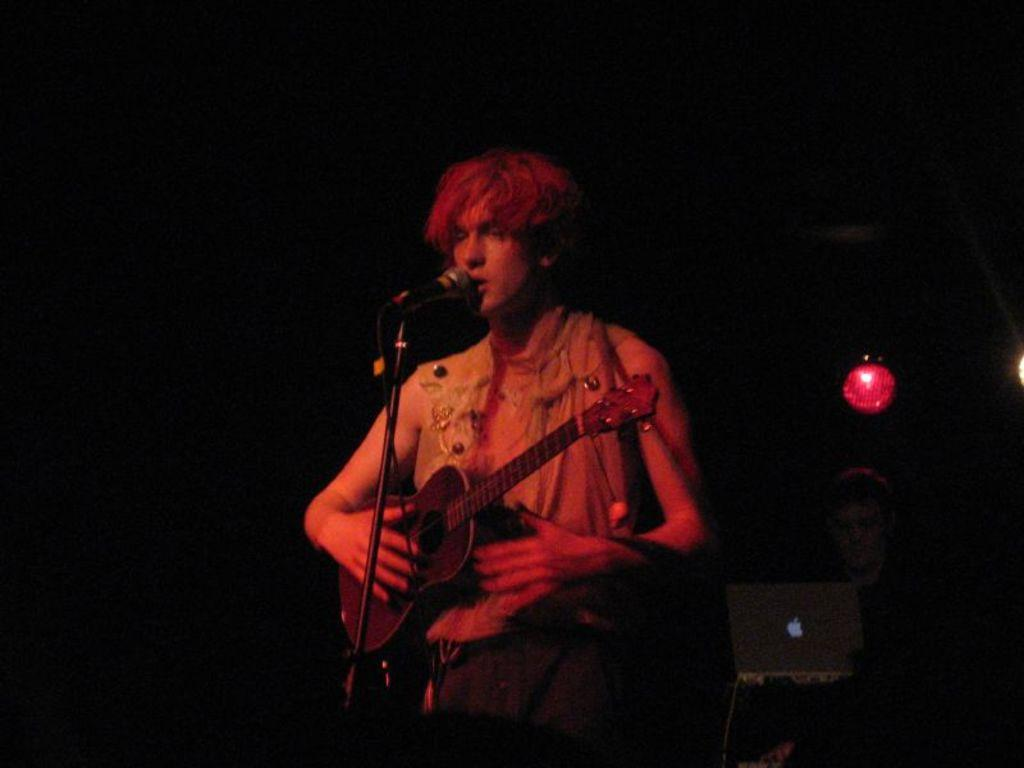What is the man in the image doing? The man is playing a guitar in the image. What object is present in the image that is commonly used for amplifying sound? There is a microphone in the image. What type of cake is being served on the mountain in the image? There is no cake or mountain present in the image; it features a man playing a guitar and a microphone. 